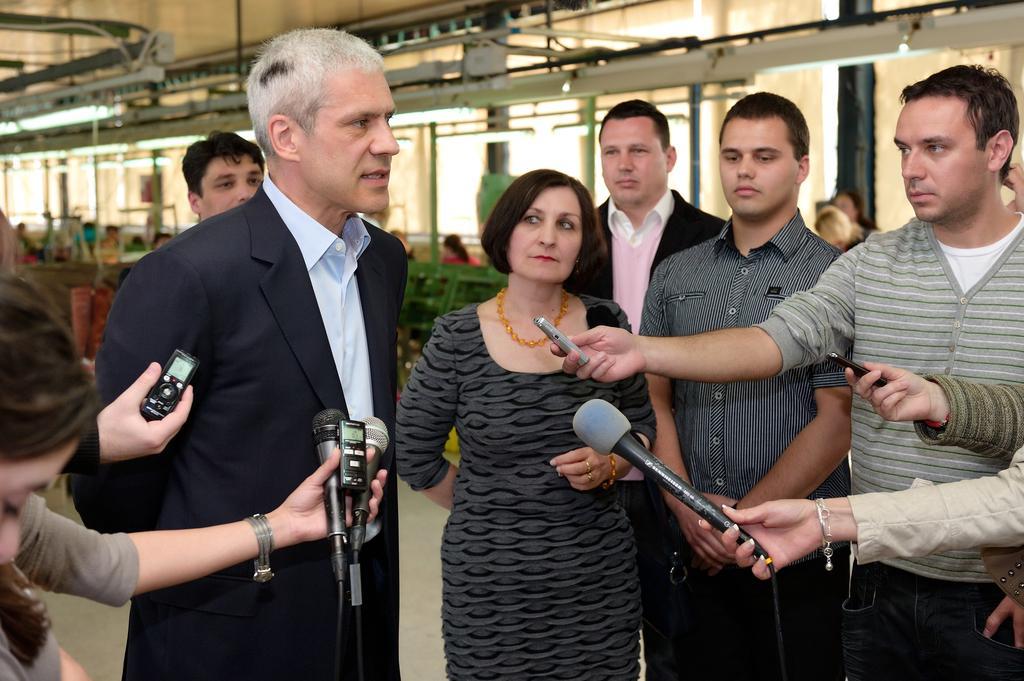Describe this image in one or two sentences. In this image we can see a group of people standing on the floor. In that some are holding the microphones with their hands. On the backside we can see a wall, ceiling lights, pole and a roof. 